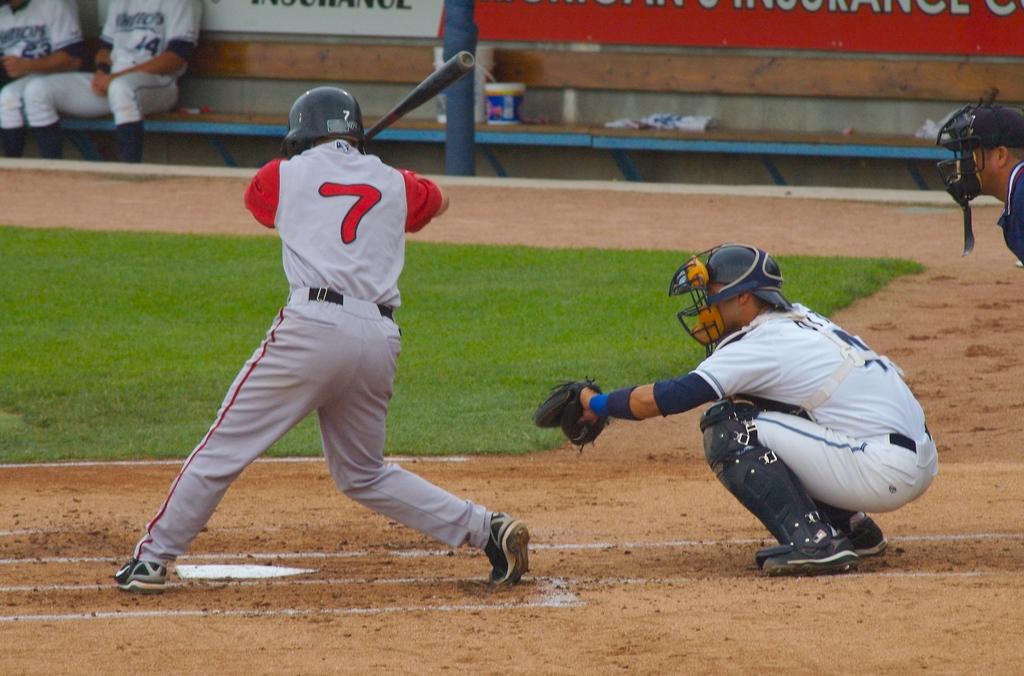What is the batter's jersey number?
Your answer should be very brief. 7. 